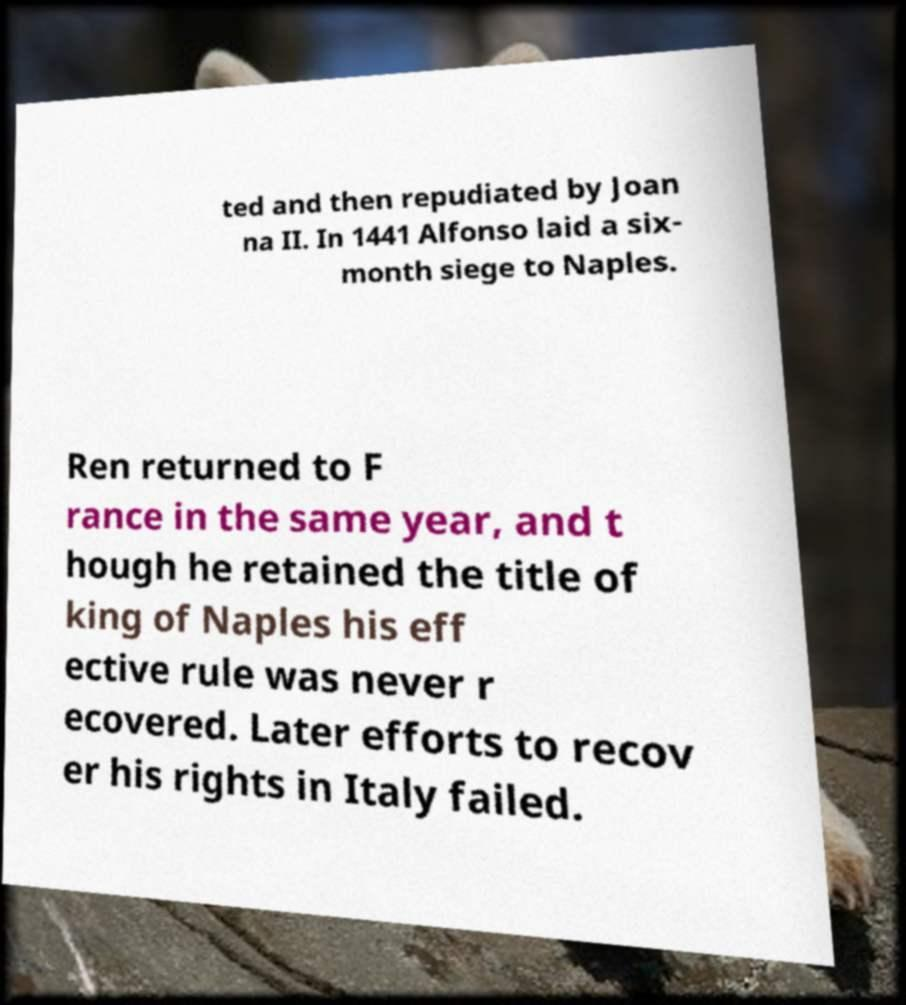Please identify and transcribe the text found in this image. ted and then repudiated by Joan na II. In 1441 Alfonso laid a six- month siege to Naples. Ren returned to F rance in the same year, and t hough he retained the title of king of Naples his eff ective rule was never r ecovered. Later efforts to recov er his rights in Italy failed. 